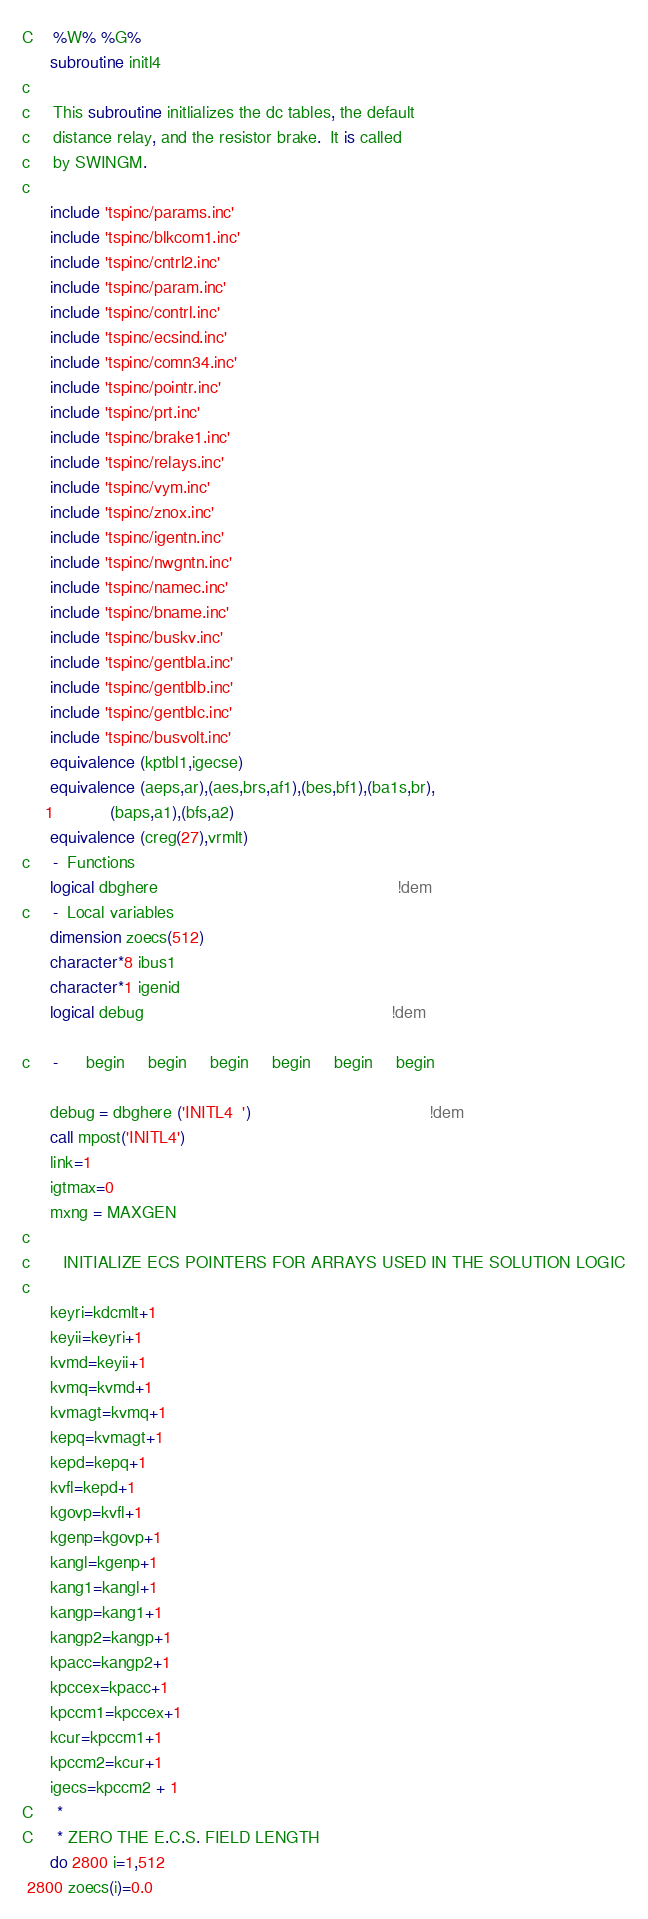<code> <loc_0><loc_0><loc_500><loc_500><_FORTRAN_>C    %W% %G%
      subroutine initl4
c      
c     This subroutine initlializes the dc tables, the default
c     distance relay, and the resistor brake.  It is called
c     by SWINGM.
c      
      include 'tspinc/params.inc'
      include 'tspinc/blkcom1.inc'
      include 'tspinc/cntrl2.inc'
      include 'tspinc/param.inc'
      include 'tspinc/contrl.inc'
      include 'tspinc/ecsind.inc'
      include 'tspinc/comn34.inc'
      include 'tspinc/pointr.inc'
      include 'tspinc/prt.inc'
      include 'tspinc/brake1.inc'
      include 'tspinc/relays.inc'
      include 'tspinc/vym.inc'
      include 'tspinc/znox.inc'
      include 'tspinc/igentn.inc'
      include 'tspinc/nwgntn.inc'
      include 'tspinc/namec.inc'
      include 'tspinc/bname.inc'
      include 'tspinc/buskv.inc'
      include 'tspinc/gentbla.inc'
      include 'tspinc/gentblb.inc'
      include 'tspinc/gentblc.inc'
      include 'tspinc/busvolt.inc'
      equivalence (kptbl1,igecse)
      equivalence (aeps,ar),(aes,brs,af1),(bes,bf1),(ba1s,br),
     1            (baps,a1),(bfs,a2)
      equivalence (creg(27),vrmlt)
c     -  Functions
      logical dbghere                                                   !dem
c     -  Local variables 
      dimension zoecs(512)
      character*8 ibus1
      character*1 igenid
      logical debug                                                     !dem

c     -      begin     begin     begin     begin     begin     begin

      debug = dbghere ('INITL4  ')                                      !dem
      call mpost('INITL4')
      link=1
      igtmax=0
      mxng = MAXGEN
c      
c       INITIALIZE ECS POINTERS FOR ARRAYS USED IN THE SOLUTION LOGIC
c      
      keyri=kdcmlt+1
      keyii=keyri+1
      kvmd=keyii+1
      kvmq=kvmd+1
      kvmagt=kvmq+1
      kepq=kvmagt+1
      kepd=kepq+1
      kvfl=kepd+1
      kgovp=kvfl+1
      kgenp=kgovp+1
      kangl=kgenp+1
      kang1=kangl+1
      kangp=kang1+1
      kangp2=kangp+1
      kpacc=kangp2+1
      kpccex=kpacc+1
      kpccm1=kpccex+1
      kcur=kpccm1+1
      kpccm2=kcur+1
      igecs=kpccm2 + 1
C     *
C     * ZERO THE E.C.S. FIELD LENGTH
      do 2800 i=1,512
 2800 zoecs(i)=0.0</code> 